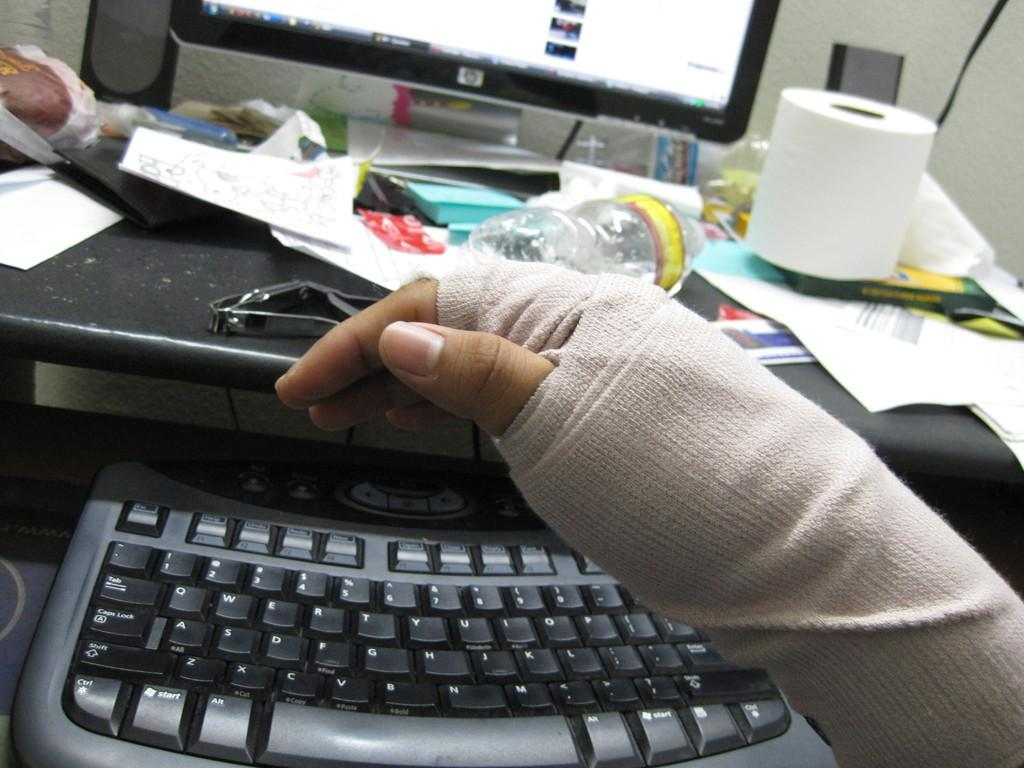<image>
Write a terse but informative summary of the picture. A person with an injured hand sits in front of an HP computer. 